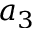<formula> <loc_0><loc_0><loc_500><loc_500>a _ { 3 }</formula> 